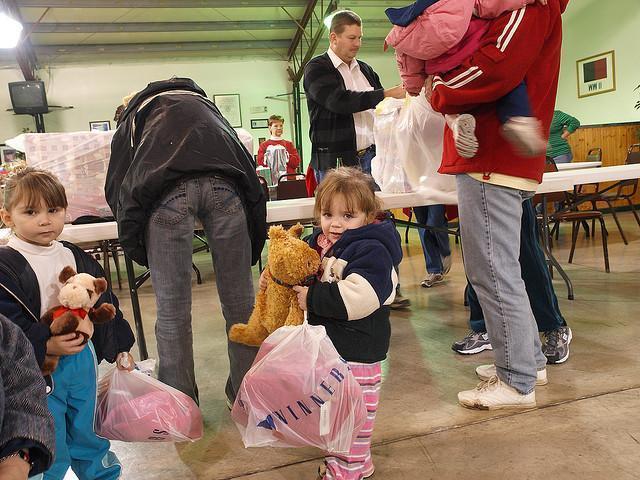What are the two girls in front doing?
Answer the question by selecting the correct answer among the 4 following choices.
Options: Selling animals, waiting, standing line, stealing animals. Waiting. 